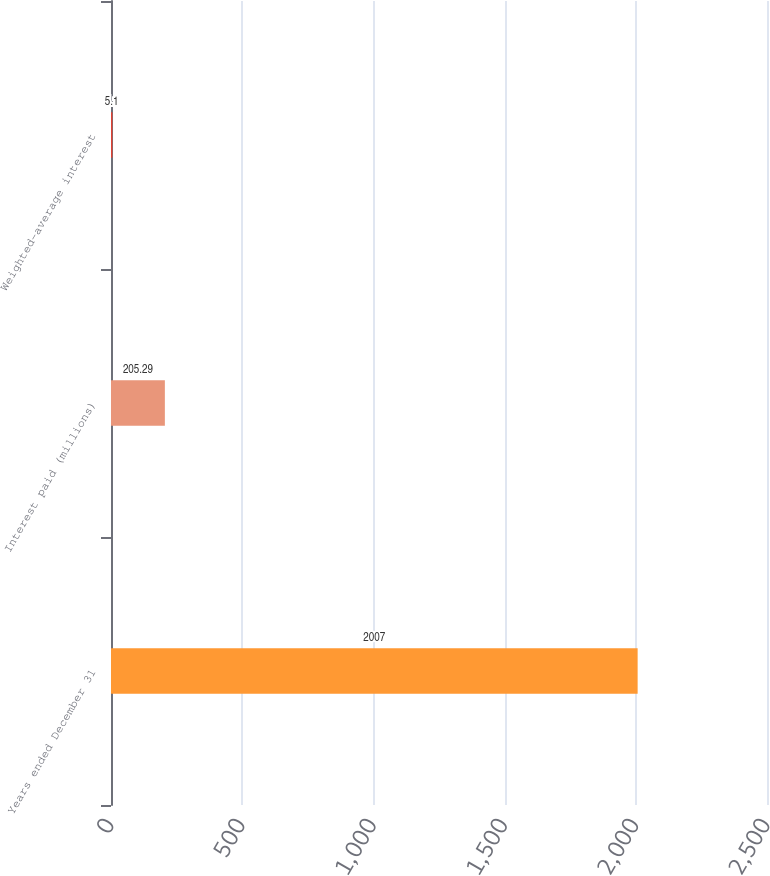Convert chart. <chart><loc_0><loc_0><loc_500><loc_500><bar_chart><fcel>Years ended December 31<fcel>Interest paid (millions)<fcel>Weighted-average interest<nl><fcel>2007<fcel>205.29<fcel>5.1<nl></chart> 